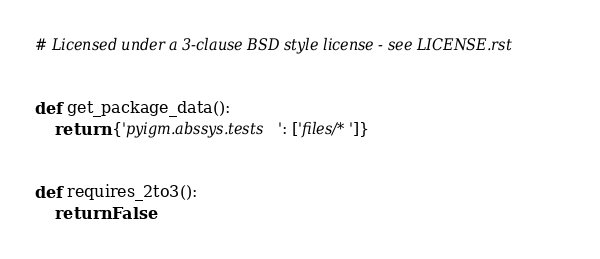Convert code to text. <code><loc_0><loc_0><loc_500><loc_500><_Python_># Licensed under a 3-clause BSD style license - see LICENSE.rst


def get_package_data():
    return {'pyigm.abssys.tests': ['files/*']}


def requires_2to3():
    return False
</code> 